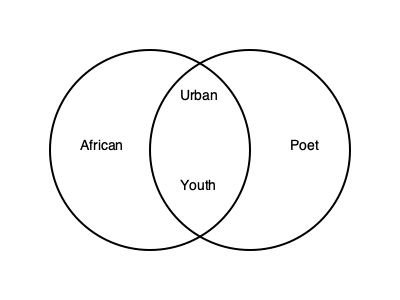Using the Venn diagram above, which identity category represents the intersection of being African, a poet, urban, and young? To answer this question, we need to analyze the Venn diagram and understand how intersecting identities are represented:

1. The left circle represents the "African" identity.
2. The right circle represents the "Poet" identity.
3. The overlapping area between the two circles represents individuals who are both African and poets.
4. Within this overlapping area, we see two additional labels: "Urban" and "Youth."

The intersection of all four identities (African, Poet, Urban, and Youth) is represented by the central area where all these labels converge. This area symbolizes individuals who embody all four of these identity categories simultaneously.

In the context of the given persona ("A young poet from Nairobi using their voice and writing to explore issues of identity and equality"), this intersection perfectly aligns with the description. Nairobi is an urban center in Africa, and the persona is described as young and a poet.

Therefore, the identity category that represents the intersection of being African, a poet, urban, and young is "Youth," as it is positioned at the center of all these overlapping identities in the Venn diagram.
Answer: Youth 